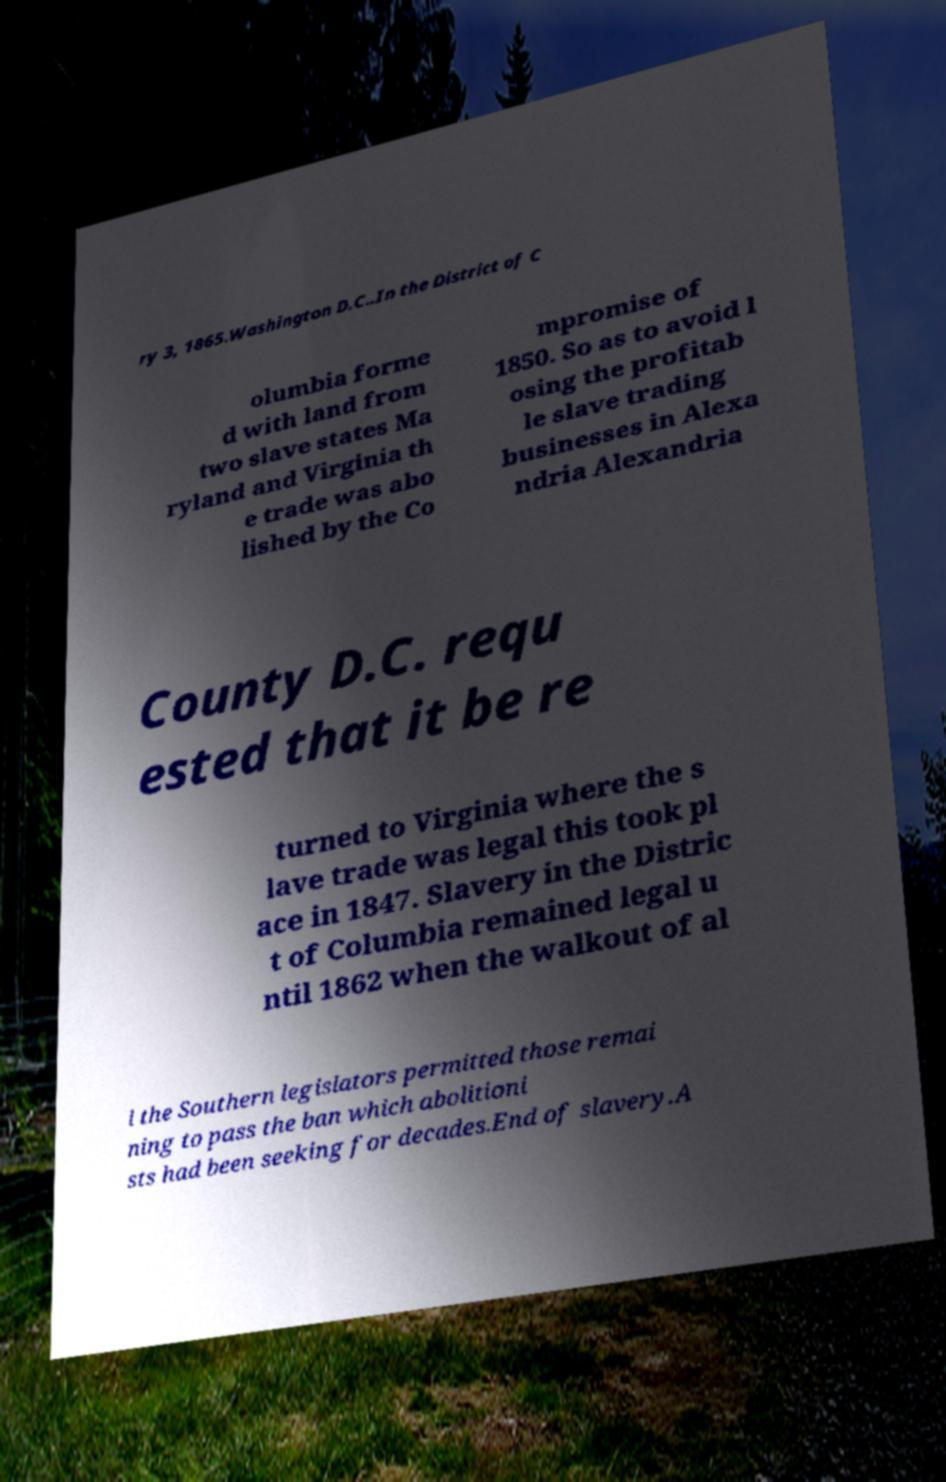Could you extract and type out the text from this image? ry 3, 1865.Washington D.C..In the District of C olumbia forme d with land from two slave states Ma ryland and Virginia th e trade was abo lished by the Co mpromise of 1850. So as to avoid l osing the profitab le slave trading businesses in Alexa ndria Alexandria County D.C. requ ested that it be re turned to Virginia where the s lave trade was legal this took pl ace in 1847. Slavery in the Distric t of Columbia remained legal u ntil 1862 when the walkout of al l the Southern legislators permitted those remai ning to pass the ban which abolitioni sts had been seeking for decades.End of slavery.A 